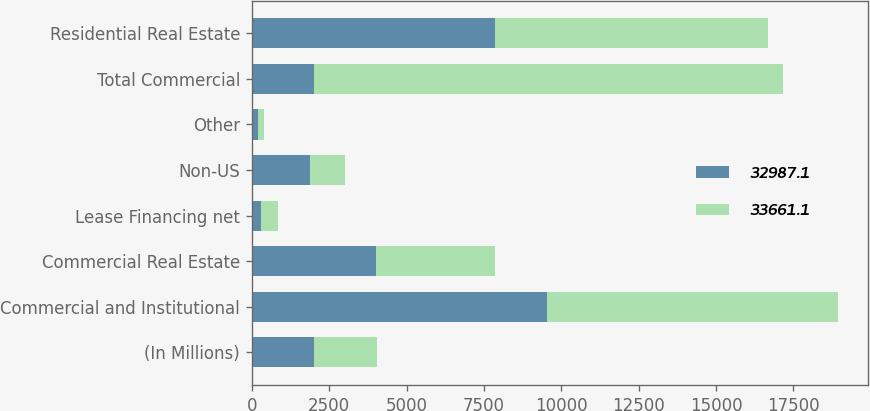Convert chart to OTSL. <chart><loc_0><loc_0><loc_500><loc_500><stacked_bar_chart><ecel><fcel>(In Millions)<fcel>Commercial and Institutional<fcel>Commercial Real Estate<fcel>Lease Financing net<fcel>Non-US<fcel>Other<fcel>Total Commercial<fcel>Residential Real Estate<nl><fcel>32987.1<fcel>2016<fcel>9523<fcel>4002.5<fcel>293.9<fcel>1877.8<fcel>205.1<fcel>2016<fcel>7841.9<nl><fcel>33661.1<fcel>2015<fcel>9431.5<fcel>3848.8<fcel>544.4<fcel>1137.7<fcel>194.1<fcel>15156.5<fcel>8850.7<nl></chart> 